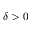Convert formula to latex. <formula><loc_0><loc_0><loc_500><loc_500>\delta > 0</formula> 